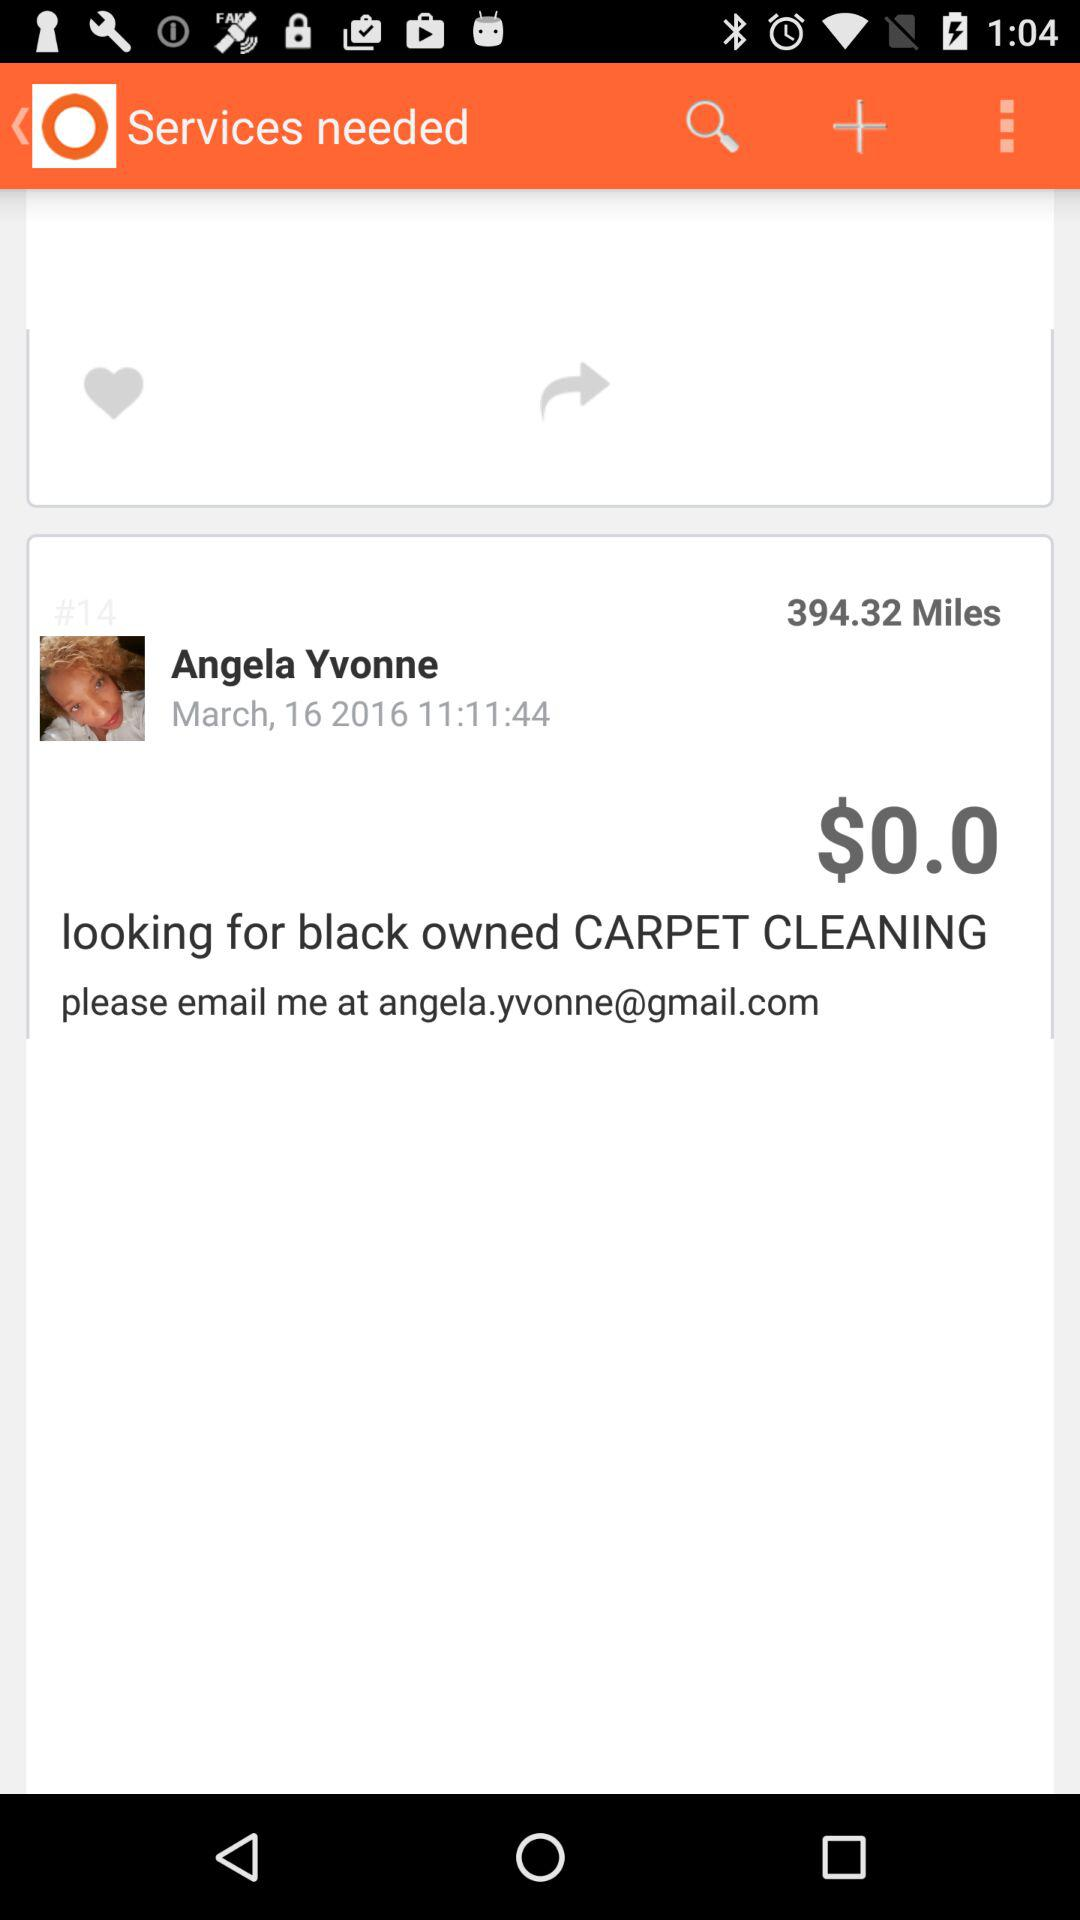What is the time duration?
When the provided information is insufficient, respond with <no answer>. <no answer> 